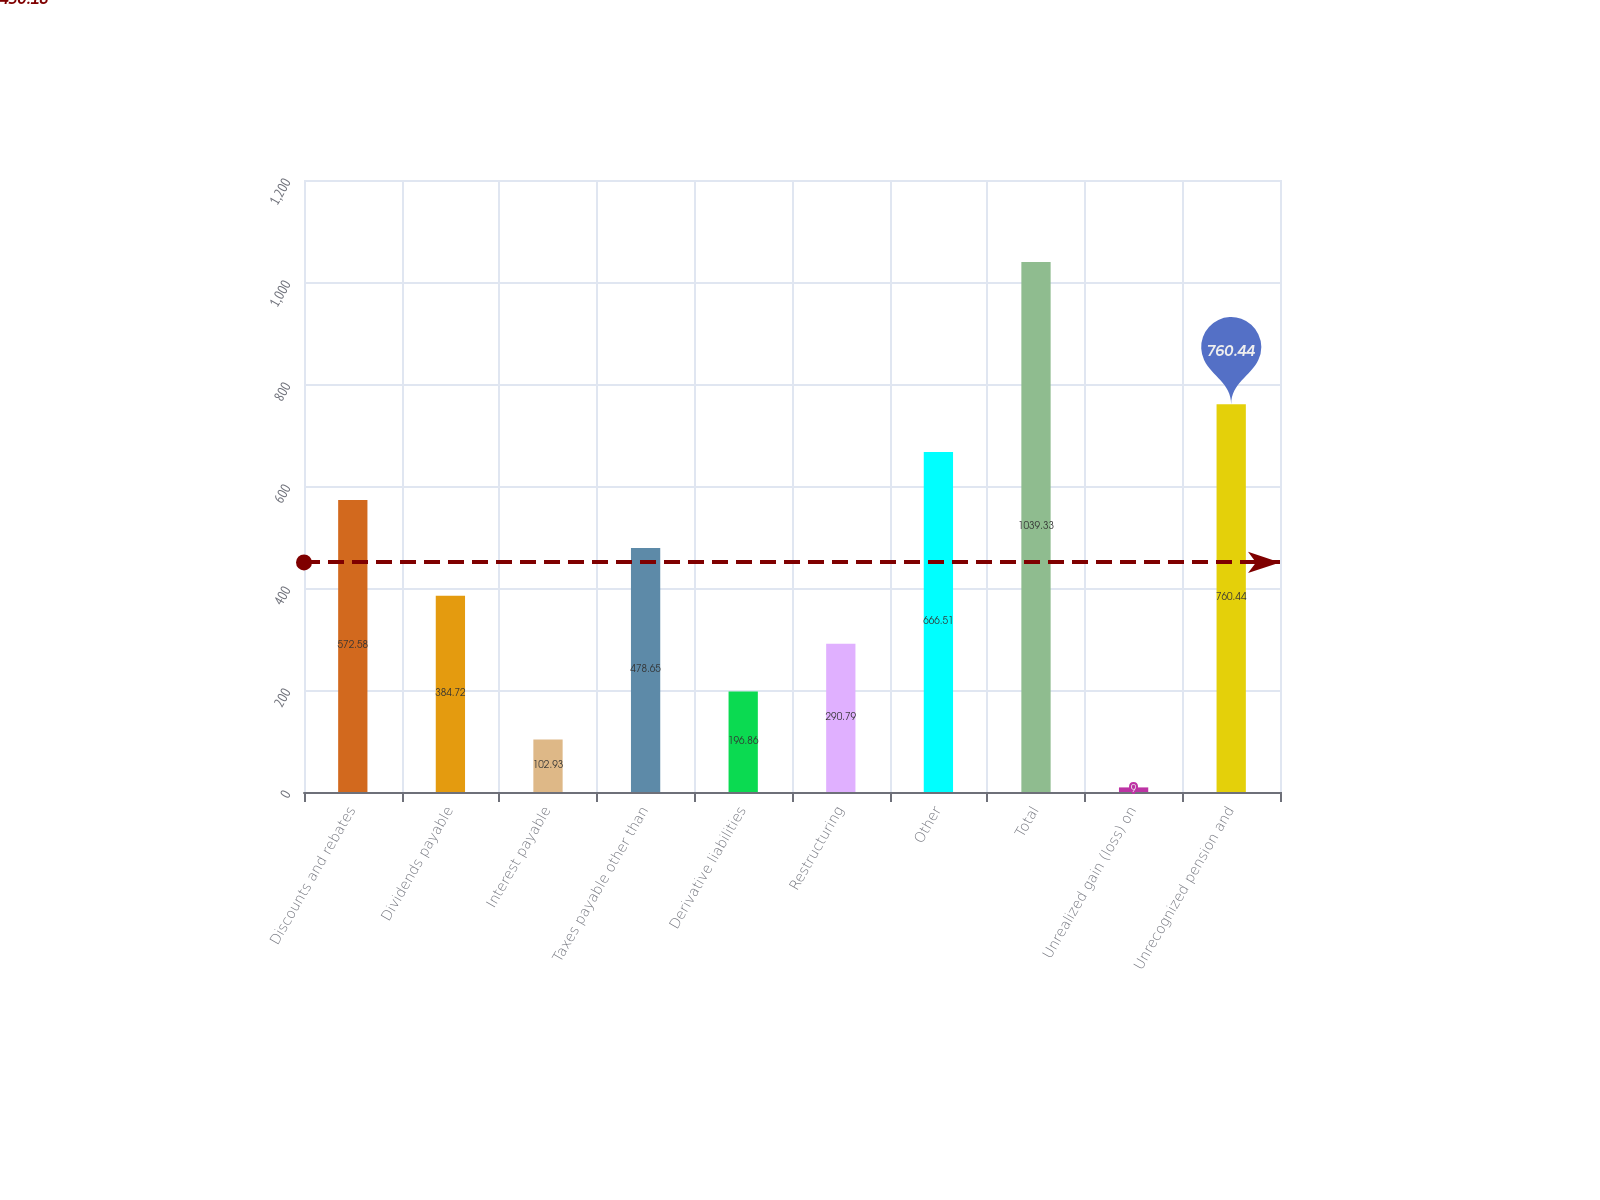<chart> <loc_0><loc_0><loc_500><loc_500><bar_chart><fcel>Discounts and rebates<fcel>Dividends payable<fcel>Interest payable<fcel>Taxes payable other than<fcel>Derivative liabilities<fcel>Restructuring<fcel>Other<fcel>Total<fcel>Unrealized gain (loss) on<fcel>Unrecognized pension and<nl><fcel>572.58<fcel>384.72<fcel>102.93<fcel>478.65<fcel>196.86<fcel>290.79<fcel>666.51<fcel>1039.33<fcel>9<fcel>760.44<nl></chart> 